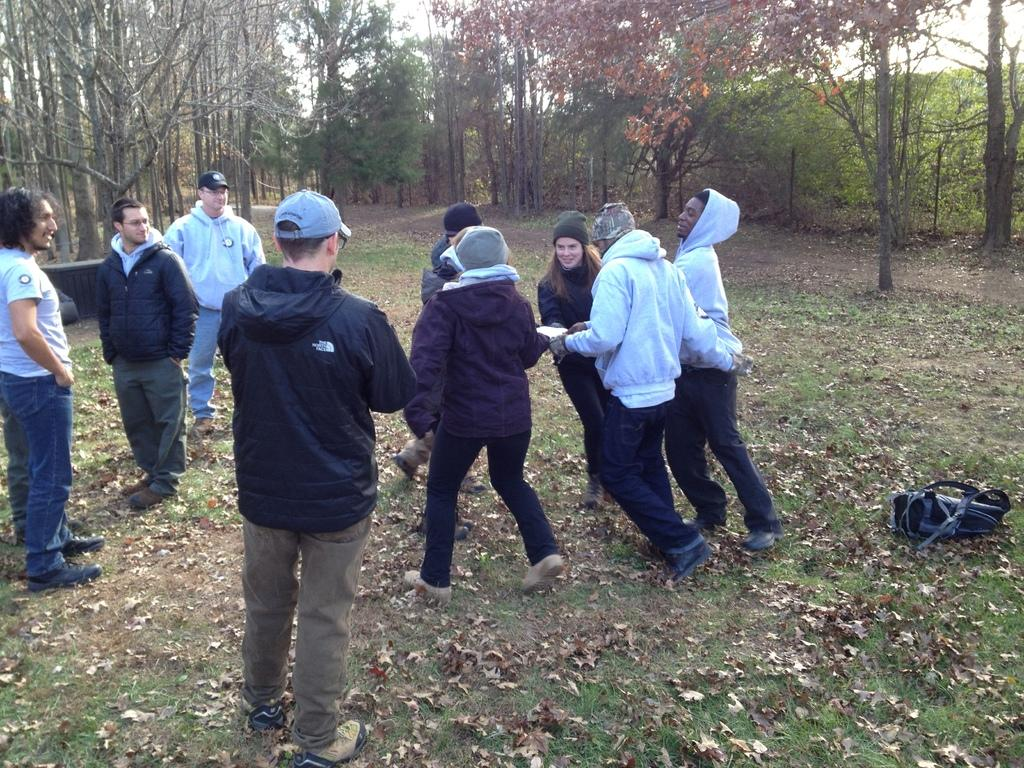What type of vegetation can be seen in the background of the image? There are trees in the background of the image. Who or what can be seen in the image? There are people visible in the image. What item is present in the image that might be used for carrying belongings? There is a backpack in the image. What type of ground surface is visible in the image? Grass is present in the image. What additional detail can be observed on the ground? Dried leaves are visible in the image. Can you see any dinosaurs in the image? No, there are no dinosaurs present in the image. What type of cushion is being used by the people in the image? There is no cushion visible in the image. 